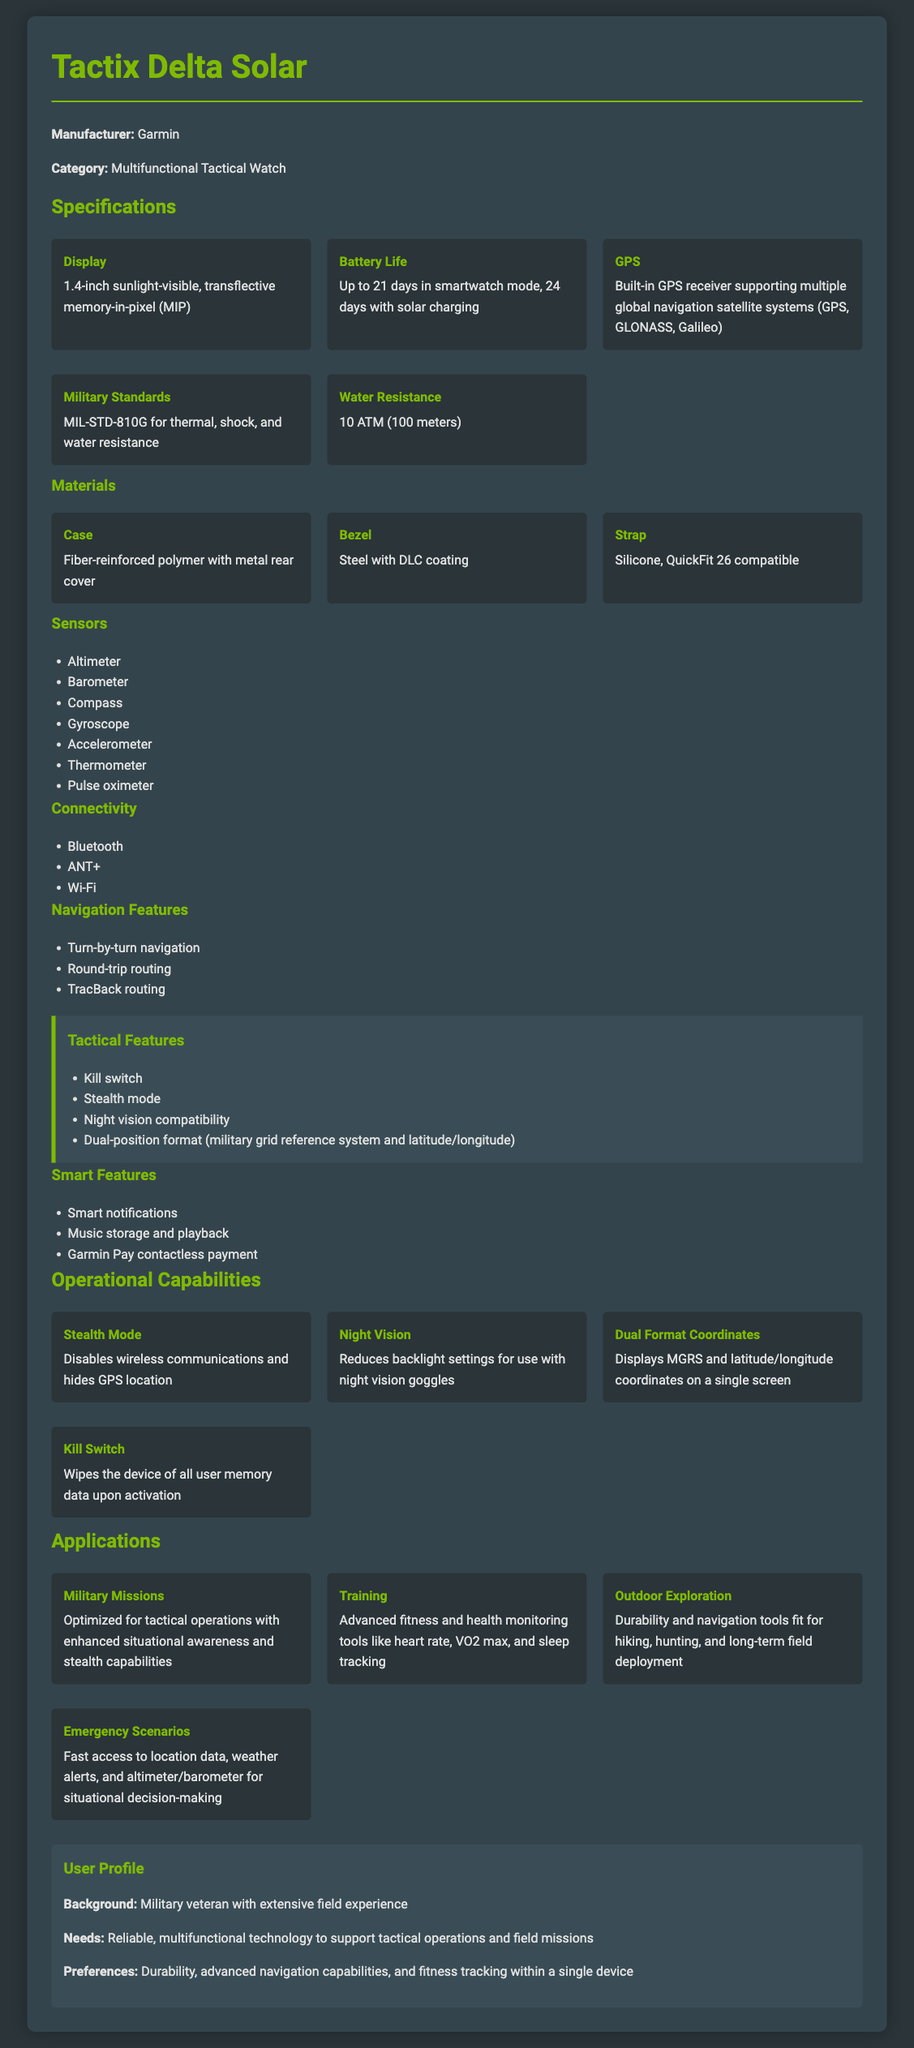what is the display size of the Tactix Delta Solar? The display size is mentioned in the specifications as "1.4-inch sunlight-visible".
Answer: 1.4-inch sunlight-visible what is the maximum battery life with solar charging? The battery life with solar charging is provided as "24 days".
Answer: 24 days what military standards does the watch comply with? The compliance is stated as "MIL-STD-810G".
Answer: MIL-STD-810G how many sensors are listed in the specifications? The sensors section lists seven sensors.
Answer: Seven sensors what feature disables wireless communications on the watch? The feature that disables wireless communications is called "Stealth Mode".
Answer: Stealth Mode which materials are used for the case and bezel? The case is "Fiber-reinforced polymer" and the bezel is "Steel with DLC coating".
Answer: Fiber-reinforced polymer; Steel with DLC coating what is the water resistance rating of the watch? The water resistance is listed as "10 ATM (100 meters)".
Answer: 10 ATM (100 meters) what applications are mentioned for the watch? The applications listed include "Military Missions", "Training", "Outdoor Exploration", and "Emergency Scenarios".
Answer: Military Missions, Training, Outdoor Exploration, Emergency Scenarios how many navigation features are listed, and can you name one? There are three navigation features listed; one is "Turn-by-turn navigation".
Answer: Three features; Turn-by-turn navigation 